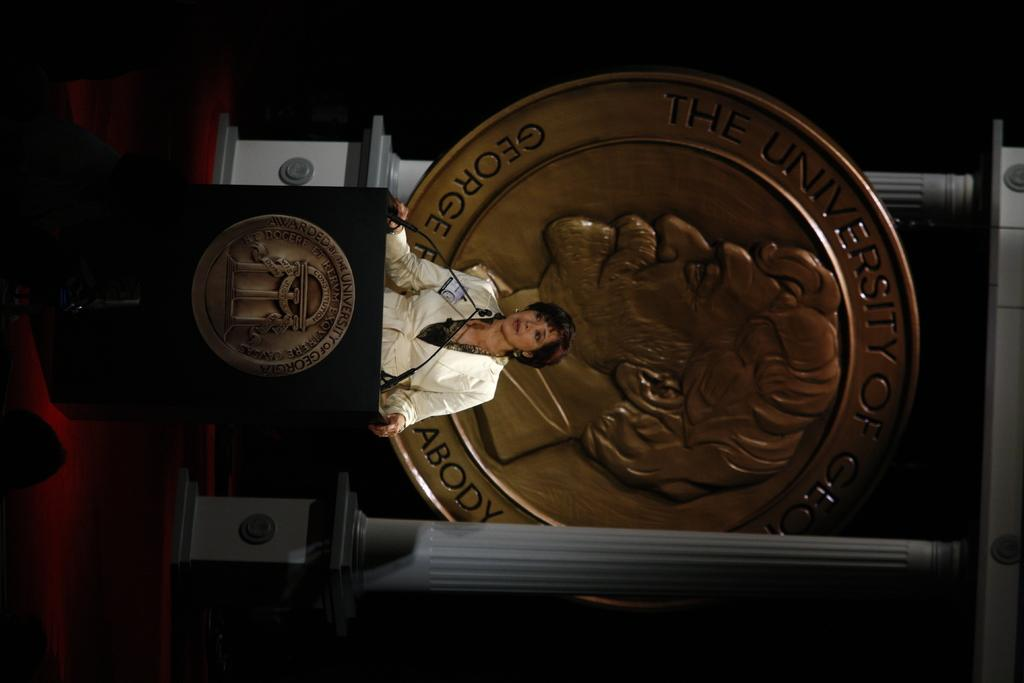What is the main subject in the foreground of the image? There is a woman standing in the foreground of the image. What is the woman standing in front of? The woman is standing in front of a table. What architectural features can be seen in the background of the image? There are pillars visible in the background of the image. What else can be seen in the background of the image? There is a board in the background of the image. What is the color of the background in the image? The background has a dark color. Where might this image have been taken? The image may have been taken in a hall, given the presence of pillars and a board. What type of agreement is being reached between the woman and the board in the image? There is no indication in the image that the woman is reaching any agreement with the board, as the board is an inanimate object. 